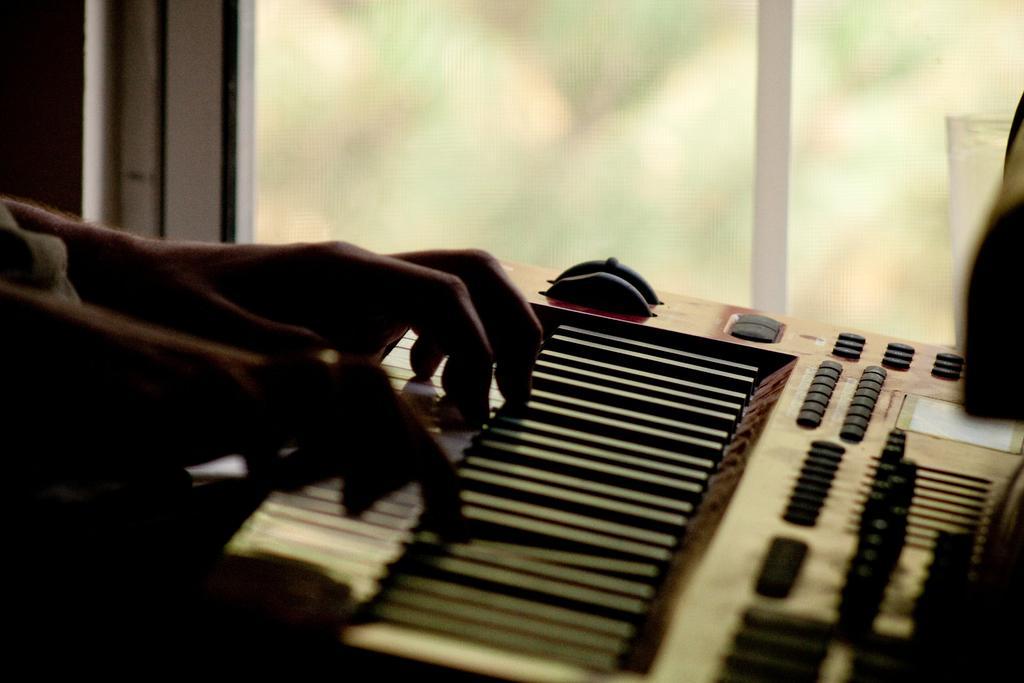How would you summarize this image in a sentence or two? In this picture, There is a piano and there is a person playing a piano, In the background there is a glass window. 